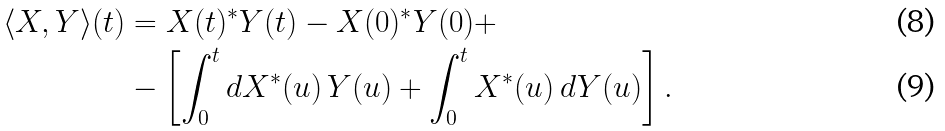Convert formula to latex. <formula><loc_0><loc_0><loc_500><loc_500>\langle X , Y \rangle ( t ) & = X ( t ) ^ { * } Y ( t ) - X ( 0 ) ^ { * } Y ( 0 ) + \\ & - \left [ \int _ { 0 } ^ { t } d X ^ { * } ( u ) \, Y ( u ) + \int _ { 0 } ^ { t } X ^ { * } ( u ) \, d Y ( u ) \right ] .</formula> 